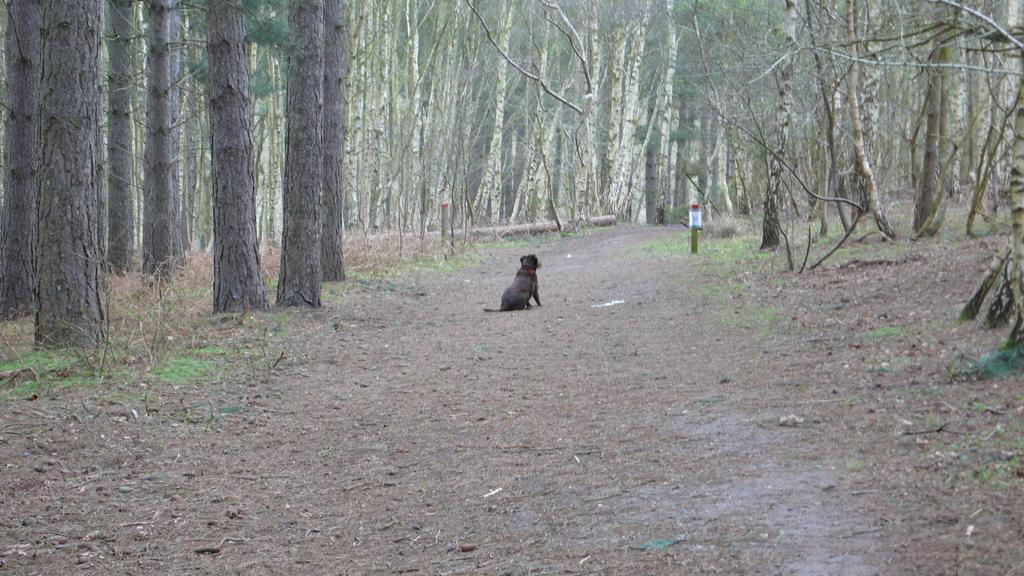What type of animal is present in the image? There is a dog in the image. Can you describe the surface on which the dog is standing? The dog is on the soil. What type of vegetation can be seen in the image? There are trees in the image. What type of quilt is the dog using to cover itself in the image? There is no quilt present in the image; the dog is on the soil. Can you tell me how many cameras are visible in the image? There are no cameras present in the image. 